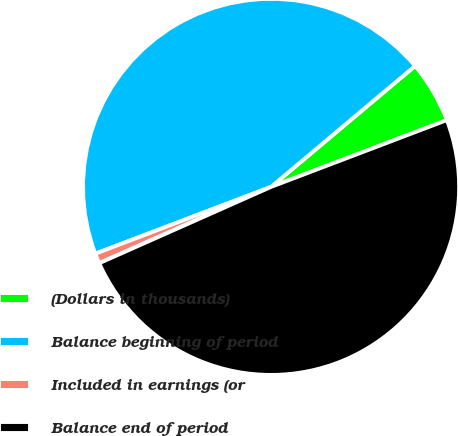Convert chart to OTSL. <chart><loc_0><loc_0><loc_500><loc_500><pie_chart><fcel>(Dollars in thousands)<fcel>Balance beginning of period<fcel>Included in earnings (or<fcel>Balance end of period<nl><fcel>5.34%<fcel>44.66%<fcel>0.87%<fcel>49.13%<nl></chart> 